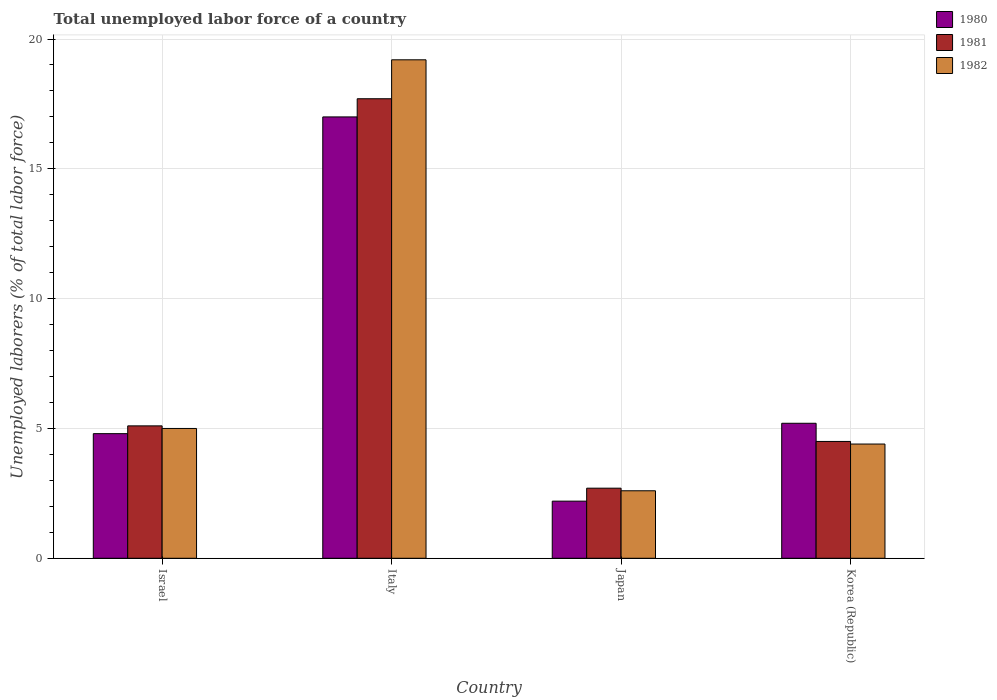How many groups of bars are there?
Provide a succinct answer. 4. Are the number of bars per tick equal to the number of legend labels?
Give a very brief answer. Yes. Are the number of bars on each tick of the X-axis equal?
Your answer should be compact. Yes. How many bars are there on the 4th tick from the left?
Offer a terse response. 3. How many bars are there on the 3rd tick from the right?
Your answer should be compact. 3. What is the label of the 4th group of bars from the left?
Provide a short and direct response. Korea (Republic). What is the total unemployed labor force in 1980 in Japan?
Your answer should be very brief. 2.2. Across all countries, what is the maximum total unemployed labor force in 1982?
Keep it short and to the point. 19.2. Across all countries, what is the minimum total unemployed labor force in 1980?
Give a very brief answer. 2.2. What is the total total unemployed labor force in 1981 in the graph?
Your answer should be very brief. 30. What is the difference between the total unemployed labor force in 1982 in Israel and that in Japan?
Your answer should be very brief. 2.4. What is the difference between the total unemployed labor force in 1981 in Japan and the total unemployed labor force in 1982 in Korea (Republic)?
Give a very brief answer. -1.7. What is the average total unemployed labor force in 1980 per country?
Make the answer very short. 7.3. What is the difference between the total unemployed labor force of/in 1982 and total unemployed labor force of/in 1981 in Israel?
Your response must be concise. -0.1. In how many countries, is the total unemployed labor force in 1982 greater than 15 %?
Keep it short and to the point. 1. What is the ratio of the total unemployed labor force in 1982 in Italy to that in Japan?
Ensure brevity in your answer.  7.38. Is the total unemployed labor force in 1982 in Israel less than that in Italy?
Provide a succinct answer. Yes. What is the difference between the highest and the second highest total unemployed labor force in 1980?
Offer a very short reply. 12.2. What is the difference between the highest and the lowest total unemployed labor force in 1981?
Provide a succinct answer. 15. Is the sum of the total unemployed labor force in 1981 in Israel and Japan greater than the maximum total unemployed labor force in 1982 across all countries?
Keep it short and to the point. No. What does the 2nd bar from the left in Italy represents?
Ensure brevity in your answer.  1981. What does the 2nd bar from the right in Korea (Republic) represents?
Your answer should be very brief. 1981. Is it the case that in every country, the sum of the total unemployed labor force in 1981 and total unemployed labor force in 1980 is greater than the total unemployed labor force in 1982?
Give a very brief answer. Yes. How many bars are there?
Ensure brevity in your answer.  12. Are all the bars in the graph horizontal?
Your answer should be very brief. No. Does the graph contain grids?
Your answer should be very brief. Yes. Where does the legend appear in the graph?
Ensure brevity in your answer.  Top right. What is the title of the graph?
Your response must be concise. Total unemployed labor force of a country. What is the label or title of the X-axis?
Give a very brief answer. Country. What is the label or title of the Y-axis?
Provide a succinct answer. Unemployed laborers (% of total labor force). What is the Unemployed laborers (% of total labor force) in 1980 in Israel?
Make the answer very short. 4.8. What is the Unemployed laborers (% of total labor force) in 1981 in Israel?
Ensure brevity in your answer.  5.1. What is the Unemployed laborers (% of total labor force) of 1982 in Israel?
Provide a succinct answer. 5. What is the Unemployed laborers (% of total labor force) in 1981 in Italy?
Give a very brief answer. 17.7. What is the Unemployed laborers (% of total labor force) of 1982 in Italy?
Keep it short and to the point. 19.2. What is the Unemployed laborers (% of total labor force) in 1980 in Japan?
Your answer should be compact. 2.2. What is the Unemployed laborers (% of total labor force) in 1981 in Japan?
Offer a terse response. 2.7. What is the Unemployed laborers (% of total labor force) in 1982 in Japan?
Ensure brevity in your answer.  2.6. What is the Unemployed laborers (% of total labor force) of 1980 in Korea (Republic)?
Give a very brief answer. 5.2. What is the Unemployed laborers (% of total labor force) in 1982 in Korea (Republic)?
Offer a very short reply. 4.4. Across all countries, what is the maximum Unemployed laborers (% of total labor force) in 1981?
Offer a very short reply. 17.7. Across all countries, what is the maximum Unemployed laborers (% of total labor force) of 1982?
Provide a short and direct response. 19.2. Across all countries, what is the minimum Unemployed laborers (% of total labor force) of 1980?
Your answer should be compact. 2.2. Across all countries, what is the minimum Unemployed laborers (% of total labor force) of 1981?
Your answer should be compact. 2.7. Across all countries, what is the minimum Unemployed laborers (% of total labor force) in 1982?
Keep it short and to the point. 2.6. What is the total Unemployed laborers (% of total labor force) of 1980 in the graph?
Your answer should be compact. 29.2. What is the total Unemployed laborers (% of total labor force) in 1982 in the graph?
Your answer should be very brief. 31.2. What is the difference between the Unemployed laborers (% of total labor force) in 1981 in Israel and that in Italy?
Your answer should be compact. -12.6. What is the difference between the Unemployed laborers (% of total labor force) in 1980 in Israel and that in Japan?
Offer a terse response. 2.6. What is the difference between the Unemployed laborers (% of total labor force) in 1980 in Israel and that in Korea (Republic)?
Your answer should be very brief. -0.4. What is the difference between the Unemployed laborers (% of total labor force) in 1981 in Israel and that in Korea (Republic)?
Make the answer very short. 0.6. What is the difference between the Unemployed laborers (% of total labor force) of 1982 in Israel and that in Korea (Republic)?
Offer a very short reply. 0.6. What is the difference between the Unemployed laborers (% of total labor force) of 1980 in Italy and that in Japan?
Provide a succinct answer. 14.8. What is the difference between the Unemployed laborers (% of total labor force) in 1981 in Italy and that in Japan?
Your response must be concise. 15. What is the difference between the Unemployed laborers (% of total labor force) of 1982 in Italy and that in Japan?
Your answer should be compact. 16.6. What is the difference between the Unemployed laborers (% of total labor force) in 1982 in Italy and that in Korea (Republic)?
Offer a terse response. 14.8. What is the difference between the Unemployed laborers (% of total labor force) of 1981 in Japan and that in Korea (Republic)?
Offer a very short reply. -1.8. What is the difference between the Unemployed laborers (% of total labor force) in 1982 in Japan and that in Korea (Republic)?
Offer a very short reply. -1.8. What is the difference between the Unemployed laborers (% of total labor force) in 1980 in Israel and the Unemployed laborers (% of total labor force) in 1981 in Italy?
Offer a very short reply. -12.9. What is the difference between the Unemployed laborers (% of total labor force) of 1980 in Israel and the Unemployed laborers (% of total labor force) of 1982 in Italy?
Your answer should be compact. -14.4. What is the difference between the Unemployed laborers (% of total labor force) of 1981 in Israel and the Unemployed laborers (% of total labor force) of 1982 in Italy?
Provide a succinct answer. -14.1. What is the difference between the Unemployed laborers (% of total labor force) in 1980 in Israel and the Unemployed laborers (% of total labor force) in 1981 in Japan?
Your response must be concise. 2.1. What is the difference between the Unemployed laborers (% of total labor force) of 1980 in Israel and the Unemployed laborers (% of total labor force) of 1982 in Japan?
Give a very brief answer. 2.2. What is the difference between the Unemployed laborers (% of total labor force) of 1981 in Israel and the Unemployed laborers (% of total labor force) of 1982 in Japan?
Provide a succinct answer. 2.5. What is the difference between the Unemployed laborers (% of total labor force) of 1980 in Italy and the Unemployed laborers (% of total labor force) of 1982 in Japan?
Provide a short and direct response. 14.4. What is the difference between the Unemployed laborers (% of total labor force) of 1981 in Italy and the Unemployed laborers (% of total labor force) of 1982 in Japan?
Make the answer very short. 15.1. What is the difference between the Unemployed laborers (% of total labor force) in 1980 in Italy and the Unemployed laborers (% of total labor force) in 1981 in Korea (Republic)?
Your answer should be very brief. 12.5. What is the difference between the Unemployed laborers (% of total labor force) of 1980 in Japan and the Unemployed laborers (% of total labor force) of 1981 in Korea (Republic)?
Your answer should be compact. -2.3. What is the average Unemployed laborers (% of total labor force) of 1981 per country?
Keep it short and to the point. 7.5. What is the difference between the Unemployed laborers (% of total labor force) in 1980 and Unemployed laborers (% of total labor force) in 1981 in Israel?
Ensure brevity in your answer.  -0.3. What is the difference between the Unemployed laborers (% of total labor force) of 1980 and Unemployed laborers (% of total labor force) of 1982 in Israel?
Your answer should be very brief. -0.2. What is the difference between the Unemployed laborers (% of total labor force) of 1981 and Unemployed laborers (% of total labor force) of 1982 in Israel?
Provide a short and direct response. 0.1. What is the difference between the Unemployed laborers (% of total labor force) of 1980 and Unemployed laborers (% of total labor force) of 1982 in Korea (Republic)?
Offer a terse response. 0.8. What is the difference between the Unemployed laborers (% of total labor force) of 1981 and Unemployed laborers (% of total labor force) of 1982 in Korea (Republic)?
Keep it short and to the point. 0.1. What is the ratio of the Unemployed laborers (% of total labor force) of 1980 in Israel to that in Italy?
Offer a terse response. 0.28. What is the ratio of the Unemployed laborers (% of total labor force) in 1981 in Israel to that in Italy?
Your answer should be compact. 0.29. What is the ratio of the Unemployed laborers (% of total labor force) in 1982 in Israel to that in Italy?
Make the answer very short. 0.26. What is the ratio of the Unemployed laborers (% of total labor force) in 1980 in Israel to that in Japan?
Make the answer very short. 2.18. What is the ratio of the Unemployed laborers (% of total labor force) in 1981 in Israel to that in Japan?
Give a very brief answer. 1.89. What is the ratio of the Unemployed laborers (% of total labor force) of 1982 in Israel to that in Japan?
Offer a terse response. 1.92. What is the ratio of the Unemployed laborers (% of total labor force) in 1981 in Israel to that in Korea (Republic)?
Ensure brevity in your answer.  1.13. What is the ratio of the Unemployed laborers (% of total labor force) of 1982 in Israel to that in Korea (Republic)?
Make the answer very short. 1.14. What is the ratio of the Unemployed laborers (% of total labor force) in 1980 in Italy to that in Japan?
Offer a very short reply. 7.73. What is the ratio of the Unemployed laborers (% of total labor force) of 1981 in Italy to that in Japan?
Provide a succinct answer. 6.56. What is the ratio of the Unemployed laborers (% of total labor force) in 1982 in Italy to that in Japan?
Your response must be concise. 7.38. What is the ratio of the Unemployed laborers (% of total labor force) of 1980 in Italy to that in Korea (Republic)?
Your answer should be compact. 3.27. What is the ratio of the Unemployed laborers (% of total labor force) in 1981 in Italy to that in Korea (Republic)?
Make the answer very short. 3.93. What is the ratio of the Unemployed laborers (% of total labor force) of 1982 in Italy to that in Korea (Republic)?
Ensure brevity in your answer.  4.36. What is the ratio of the Unemployed laborers (% of total labor force) of 1980 in Japan to that in Korea (Republic)?
Offer a very short reply. 0.42. What is the ratio of the Unemployed laborers (% of total labor force) of 1982 in Japan to that in Korea (Republic)?
Your answer should be compact. 0.59. What is the difference between the highest and the second highest Unemployed laborers (% of total labor force) in 1981?
Offer a very short reply. 12.6. 